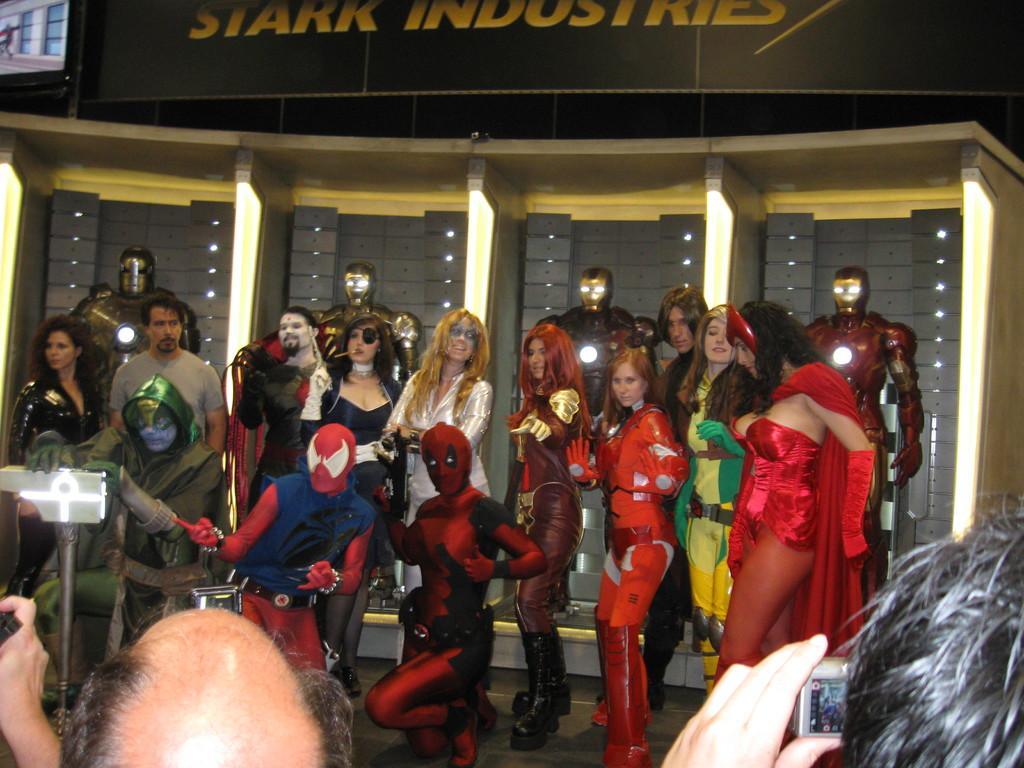In one or two sentences, can you explain what this image depicts? In this image there are persons wearing different types of costumes. In the background there are metal objects and there is a board with some text written on it. 